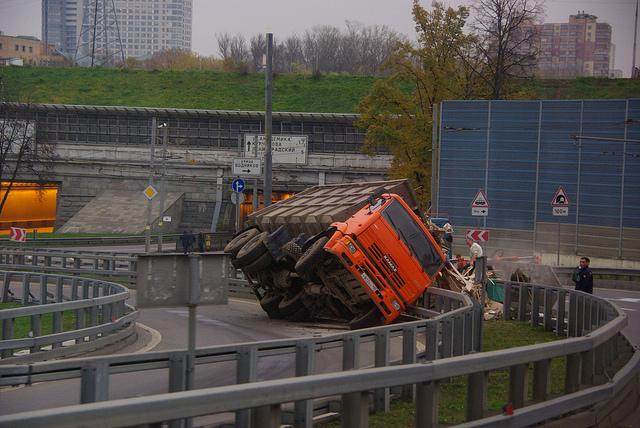Which speed during the turn caused this to happen? Please explain your reasoning. high. The truck is tipped over as if speeding. 